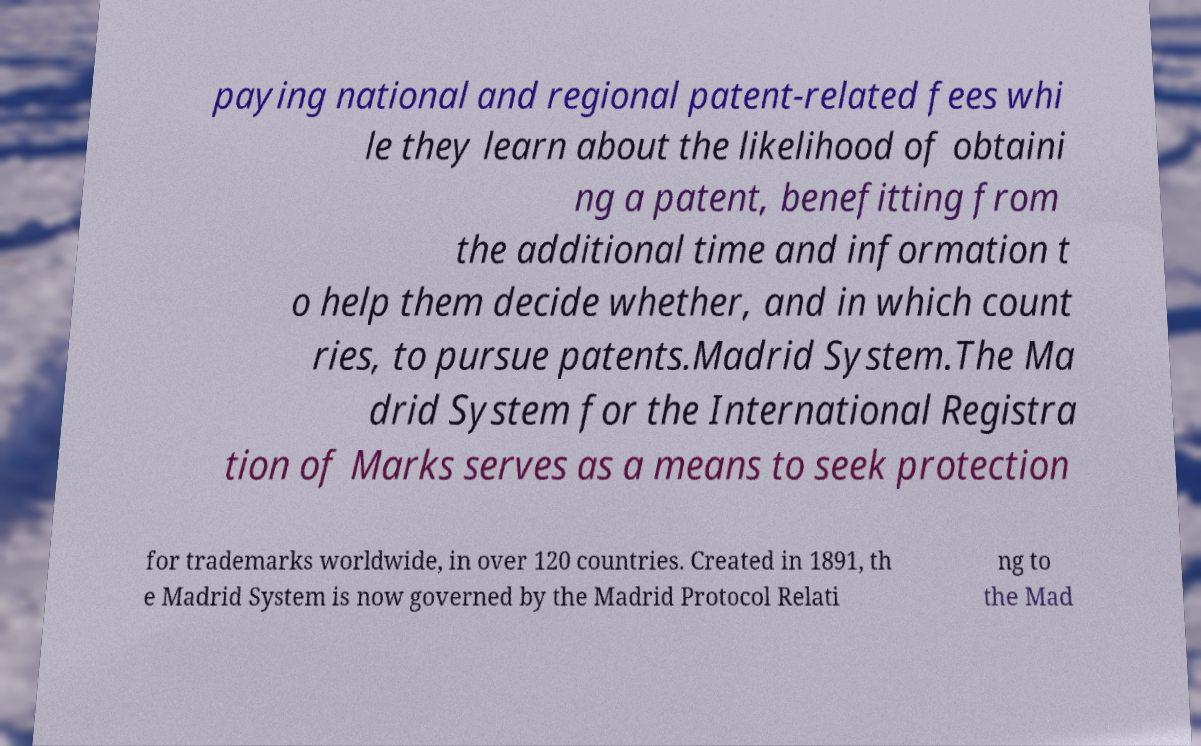What messages or text are displayed in this image? I need them in a readable, typed format. paying national and regional patent-related fees whi le they learn about the likelihood of obtaini ng a patent, benefitting from the additional time and information t o help them decide whether, and in which count ries, to pursue patents.Madrid System.The Ma drid System for the International Registra tion of Marks serves as a means to seek protection for trademarks worldwide, in over 120 countries. Created in 1891, th e Madrid System is now governed by the Madrid Protocol Relati ng to the Mad 